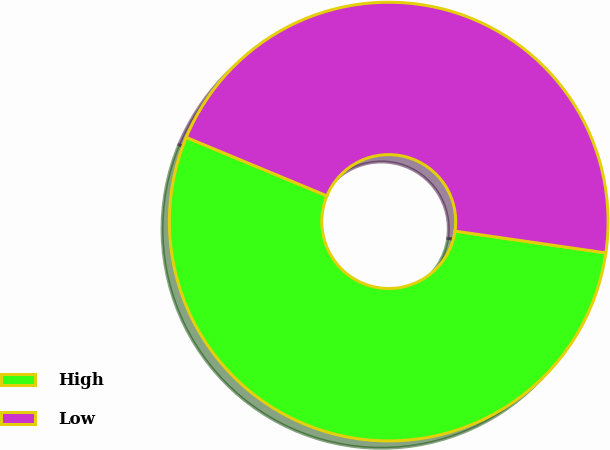Convert chart. <chart><loc_0><loc_0><loc_500><loc_500><pie_chart><fcel>High<fcel>Low<nl><fcel>53.99%<fcel>46.01%<nl></chart> 